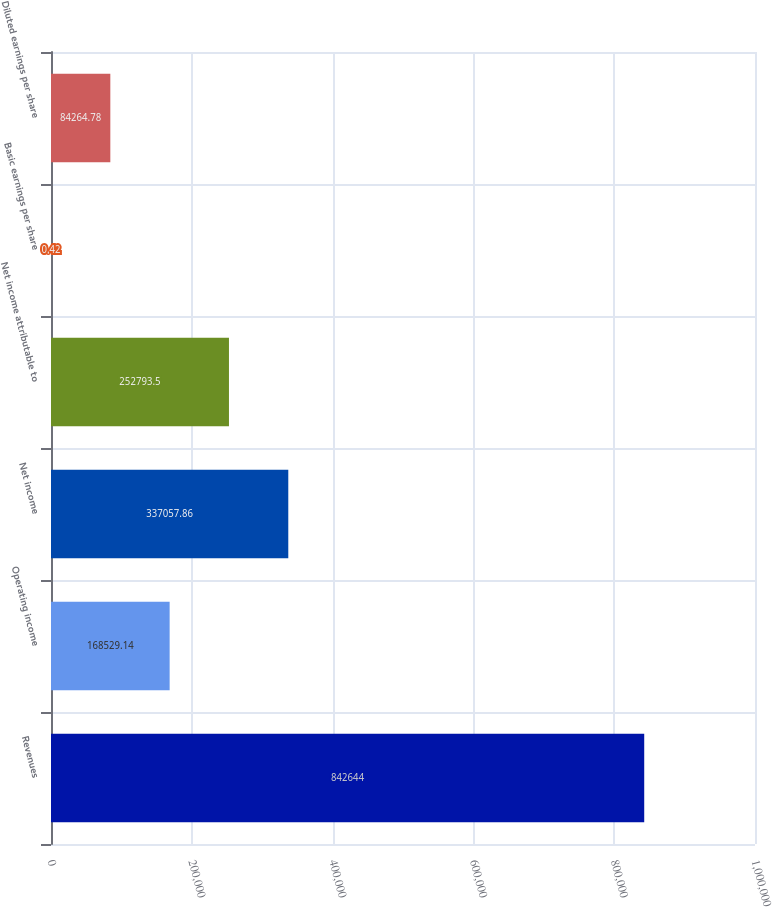<chart> <loc_0><loc_0><loc_500><loc_500><bar_chart><fcel>Revenues<fcel>Operating income<fcel>Net income<fcel>Net income attributable to<fcel>Basic earnings per share<fcel>Diluted earnings per share<nl><fcel>842644<fcel>168529<fcel>337058<fcel>252794<fcel>0.42<fcel>84264.8<nl></chart> 